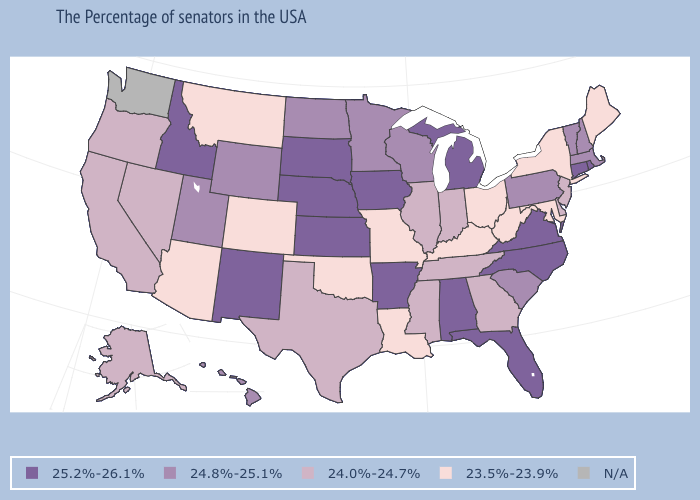Does Rhode Island have the highest value in the USA?
Answer briefly. Yes. What is the value of Washington?
Answer briefly. N/A. Name the states that have a value in the range 24.8%-25.1%?
Be succinct. Massachusetts, New Hampshire, Vermont, Pennsylvania, South Carolina, Wisconsin, Minnesota, North Dakota, Wyoming, Utah, Hawaii. Name the states that have a value in the range 25.2%-26.1%?
Quick response, please. Rhode Island, Connecticut, Virginia, North Carolina, Florida, Michigan, Alabama, Arkansas, Iowa, Kansas, Nebraska, South Dakota, New Mexico, Idaho. What is the value of Oklahoma?
Write a very short answer. 23.5%-23.9%. What is the value of Massachusetts?
Concise answer only. 24.8%-25.1%. Does Idaho have the highest value in the USA?
Keep it brief. Yes. What is the highest value in the West ?
Give a very brief answer. 25.2%-26.1%. Does the map have missing data?
Be succinct. Yes. What is the lowest value in the South?
Quick response, please. 23.5%-23.9%. What is the value of Virginia?
Answer briefly. 25.2%-26.1%. Name the states that have a value in the range 25.2%-26.1%?
Concise answer only. Rhode Island, Connecticut, Virginia, North Carolina, Florida, Michigan, Alabama, Arkansas, Iowa, Kansas, Nebraska, South Dakota, New Mexico, Idaho. Which states have the lowest value in the USA?
Be succinct. Maine, New York, Maryland, West Virginia, Ohio, Kentucky, Louisiana, Missouri, Oklahoma, Colorado, Montana, Arizona. 